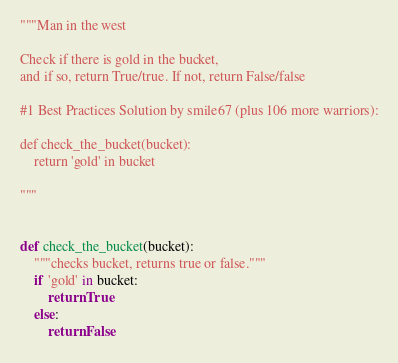Convert code to text. <code><loc_0><loc_0><loc_500><loc_500><_Python_>"""Man in the west

Check if there is gold in the bucket,
and if so, return True/true. If not, return False/false

#1 Best Practices Solution by smile67 (plus 106 more warriors):

def check_the_bucket(bucket):
    return 'gold' in bucket

"""


def check_the_bucket(bucket):
    """checks bucket, returns true or false."""
    if 'gold' in bucket:
        return True
    else:
        return False
</code> 